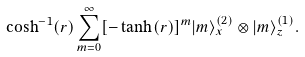Convert formula to latex. <formula><loc_0><loc_0><loc_500><loc_500>\cosh ^ { - 1 } ( r ) \sum _ { m = 0 } ^ { \infty } [ - \tanh ( r ) ] ^ { m } | m \rangle _ { x } ^ { ( 2 ) } \otimes | m \rangle _ { z } ^ { ( 1 ) } .</formula> 